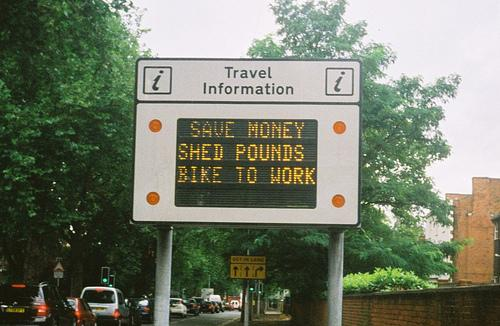Point out notable text features found in the image. The words "save money" and "travel information" are in the signpost, and there are parts of letters and a board. Identify the color of the sky and the state of the trees. The sky is blue in color, and the trees have green leaves. In a few words, describe the purpose of the signpost in the image. The signpost provides travel information and promotes saving money. Can you see any indication of a product advertisement in the image? Yes, there are words on the signpost that say "save money" and "travel information." Explain the overall scene portrayed in the image. The image shows a street scene with cars, a travel information sign, trees, the sky, a building, a wall, and various text elements. Describe the wall and building depicted in the image. The wall is brown in color and part of a brick building, which is visible off in the distance. What can you observe about the car in the picture? There is a white car on the ground, with green lights near it. Mention the elements related to traffic and transportation present in the image. There's a travel information sign on two poles, green traffic lights, and cars on the ground. Detail the relationship between the signpost and the tree in the image. A tree is located behind the signpost, with the leaves on the tree being visible. 